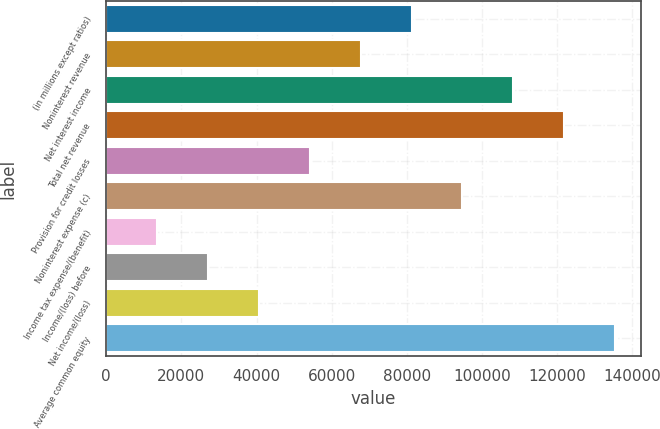Convert chart to OTSL. <chart><loc_0><loc_0><loc_500><loc_500><bar_chart><fcel>(in millions except ratios)<fcel>Noninterest revenue<fcel>Net interest income<fcel>Total net revenue<fcel>Provision for credit losses<fcel>Noninterest expense (c)<fcel>Income tax expense/(benefit)<fcel>Income/(loss) before<fcel>Net income/(loss)<fcel>Average common equity<nl><fcel>81260<fcel>67723<fcel>108334<fcel>121871<fcel>54186<fcel>94797<fcel>13575<fcel>27112<fcel>40649<fcel>135408<nl></chart> 